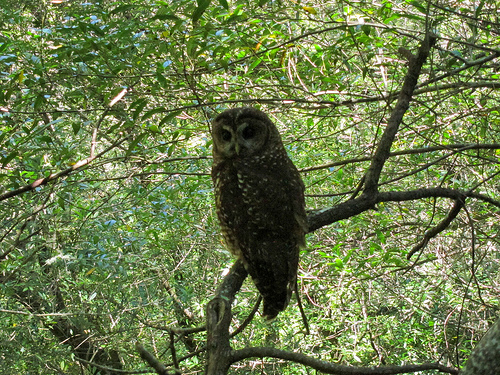<image>
Is the bear in the jungle? No. The bear is not contained within the jungle. These objects have a different spatial relationship. Where is the bird in relation to the tree? Is it on the tree? Yes. Looking at the image, I can see the bird is positioned on top of the tree, with the tree providing support. 